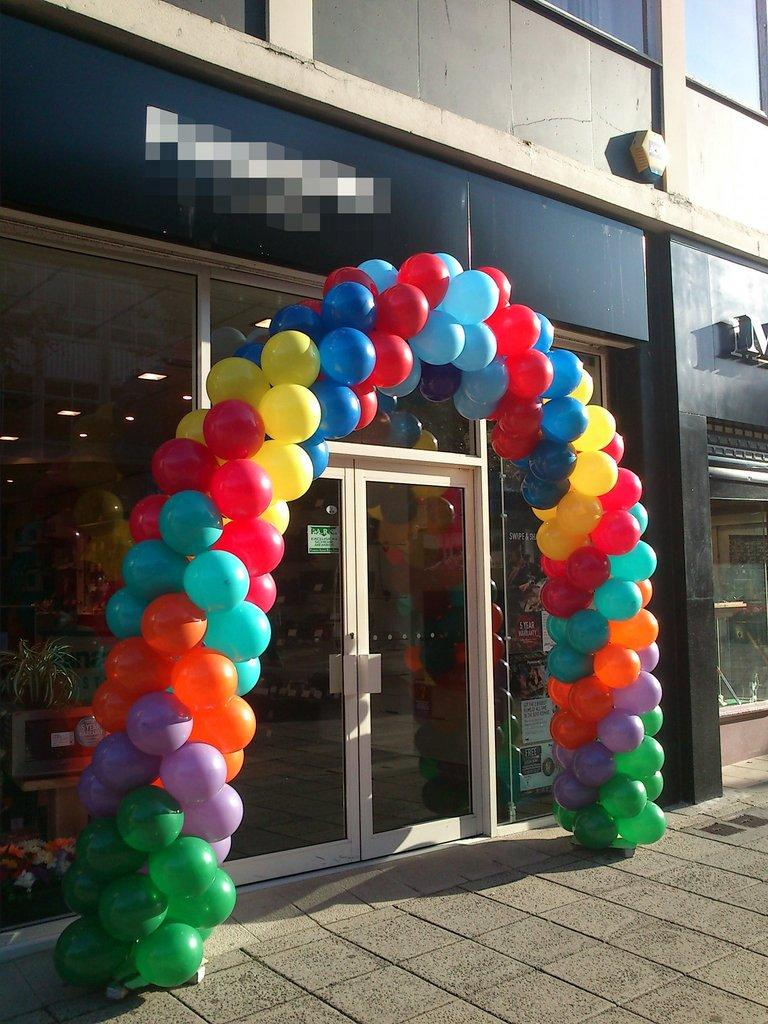What is the main structure in the center of the image? There is a building in the center of the image. What type of entrance can be seen in the image? There is a glass door in the image. What decorative element is present in the image? There is a balloon arch in the image. What surface is visible at the bottom of the image? There is a floor visible at the bottom of the image. What type of dust can be seen on the sign in the image? There is no sign present in the image, and therefore no dust can be observed on it. 